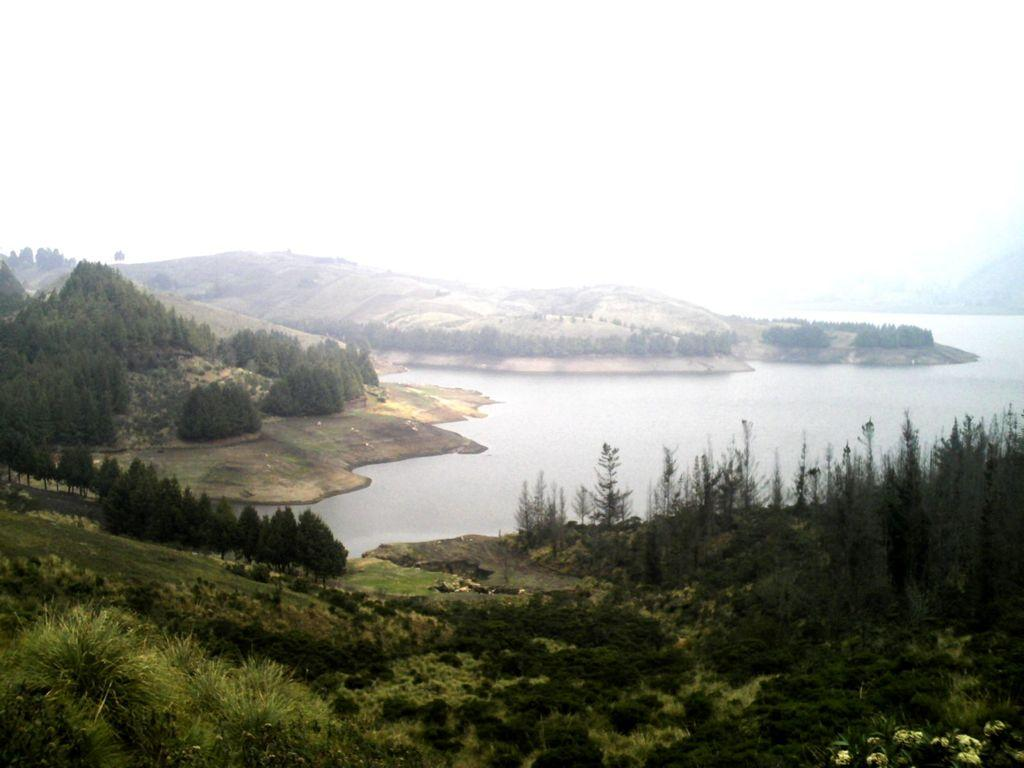What type of vegetation can be seen in the image? There are trees, plants, and grass visible in the image. What natural element can be seen in the image? There is water visible in the image. What can be seen in the background of the image? There are mountains and the sky visible in the background of the image. What type of grain is being processed in the office in the image? There is no office or grain present in the image. 